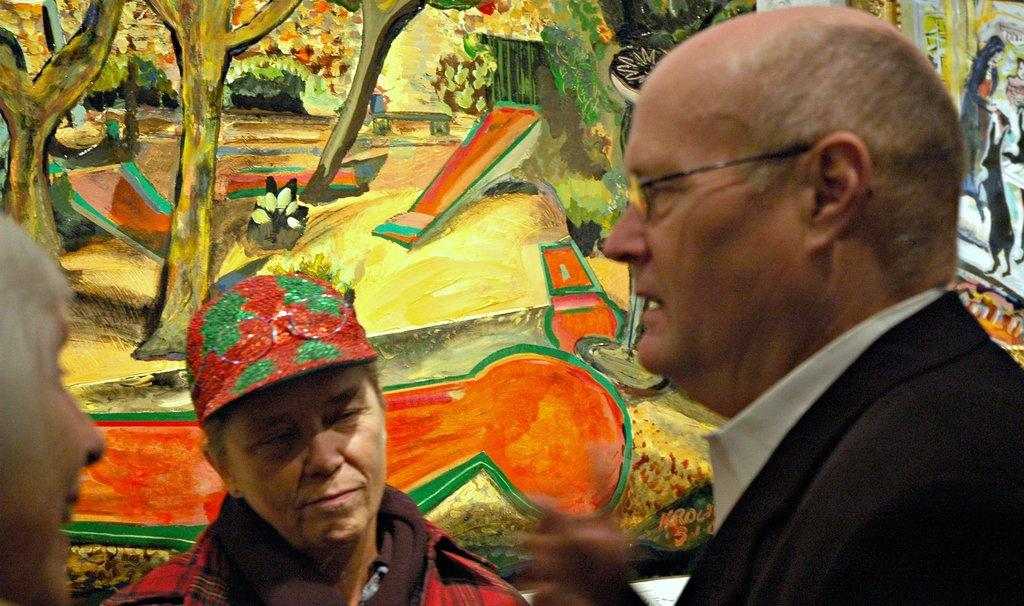How many people are in the image? There are three people in the image. Can you describe the clothing of one of the individuals? One person is wearing a cap. Where is the person wearing the cap positioned in the image? The person wearing the cap is standing in front of a wall. What can be seen on the wall in the image? There is a painting on the wall. What type of dirt can be seen on the boys' shoes in the image? There are no boys present in the image, and therefore no shoes or dirt can be observed. 